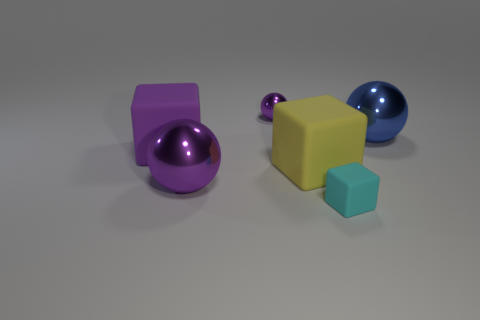There is a purple shiny object in front of the big metal ball on the right side of the big purple ball; what shape is it?
Provide a succinct answer. Sphere. Are the large ball on the left side of the large blue metal sphere and the tiny purple thing made of the same material?
Provide a short and direct response. Yes. What number of blue objects are either big metal spheres or metallic objects?
Give a very brief answer. 1. Is there a large object that has the same color as the small ball?
Your answer should be very brief. Yes. Are there any other large cubes that have the same material as the large yellow cube?
Keep it short and to the point. Yes. There is a large thing that is behind the big yellow rubber cube and left of the big blue ball; what shape is it?
Ensure brevity in your answer.  Cube. What number of big things are purple metal objects or brown blocks?
Offer a terse response. 1. What is the material of the cyan cube?
Ensure brevity in your answer.  Rubber. What number of other objects are there of the same shape as the big yellow matte thing?
Ensure brevity in your answer.  2. The cyan block has what size?
Your answer should be very brief. Small. 